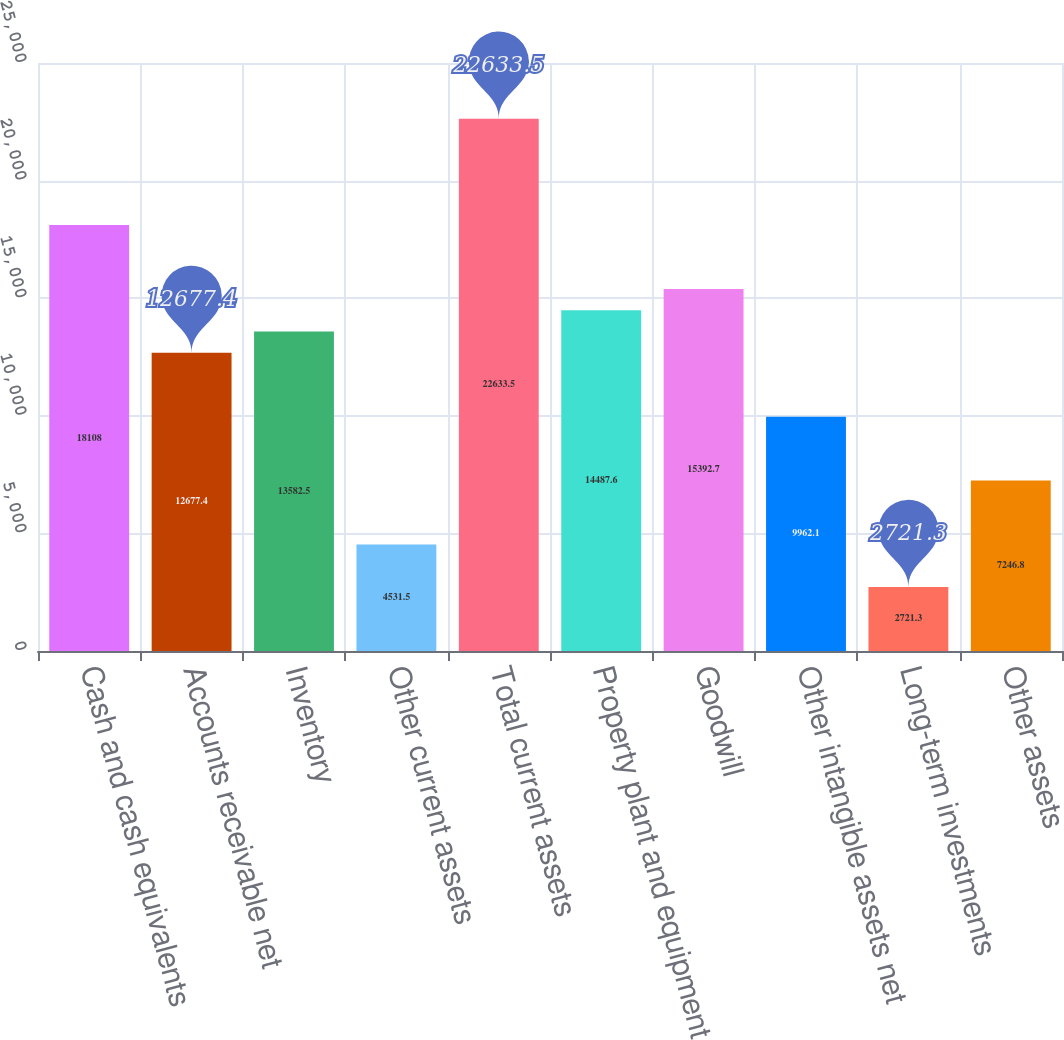<chart> <loc_0><loc_0><loc_500><loc_500><bar_chart><fcel>Cash and cash equivalents<fcel>Accounts receivable net<fcel>Inventory<fcel>Other current assets<fcel>Total current assets<fcel>Property plant and equipment<fcel>Goodwill<fcel>Other intangible assets net<fcel>Long-term investments<fcel>Other assets<nl><fcel>18108<fcel>12677.4<fcel>13582.5<fcel>4531.5<fcel>22633.5<fcel>14487.6<fcel>15392.7<fcel>9962.1<fcel>2721.3<fcel>7246.8<nl></chart> 